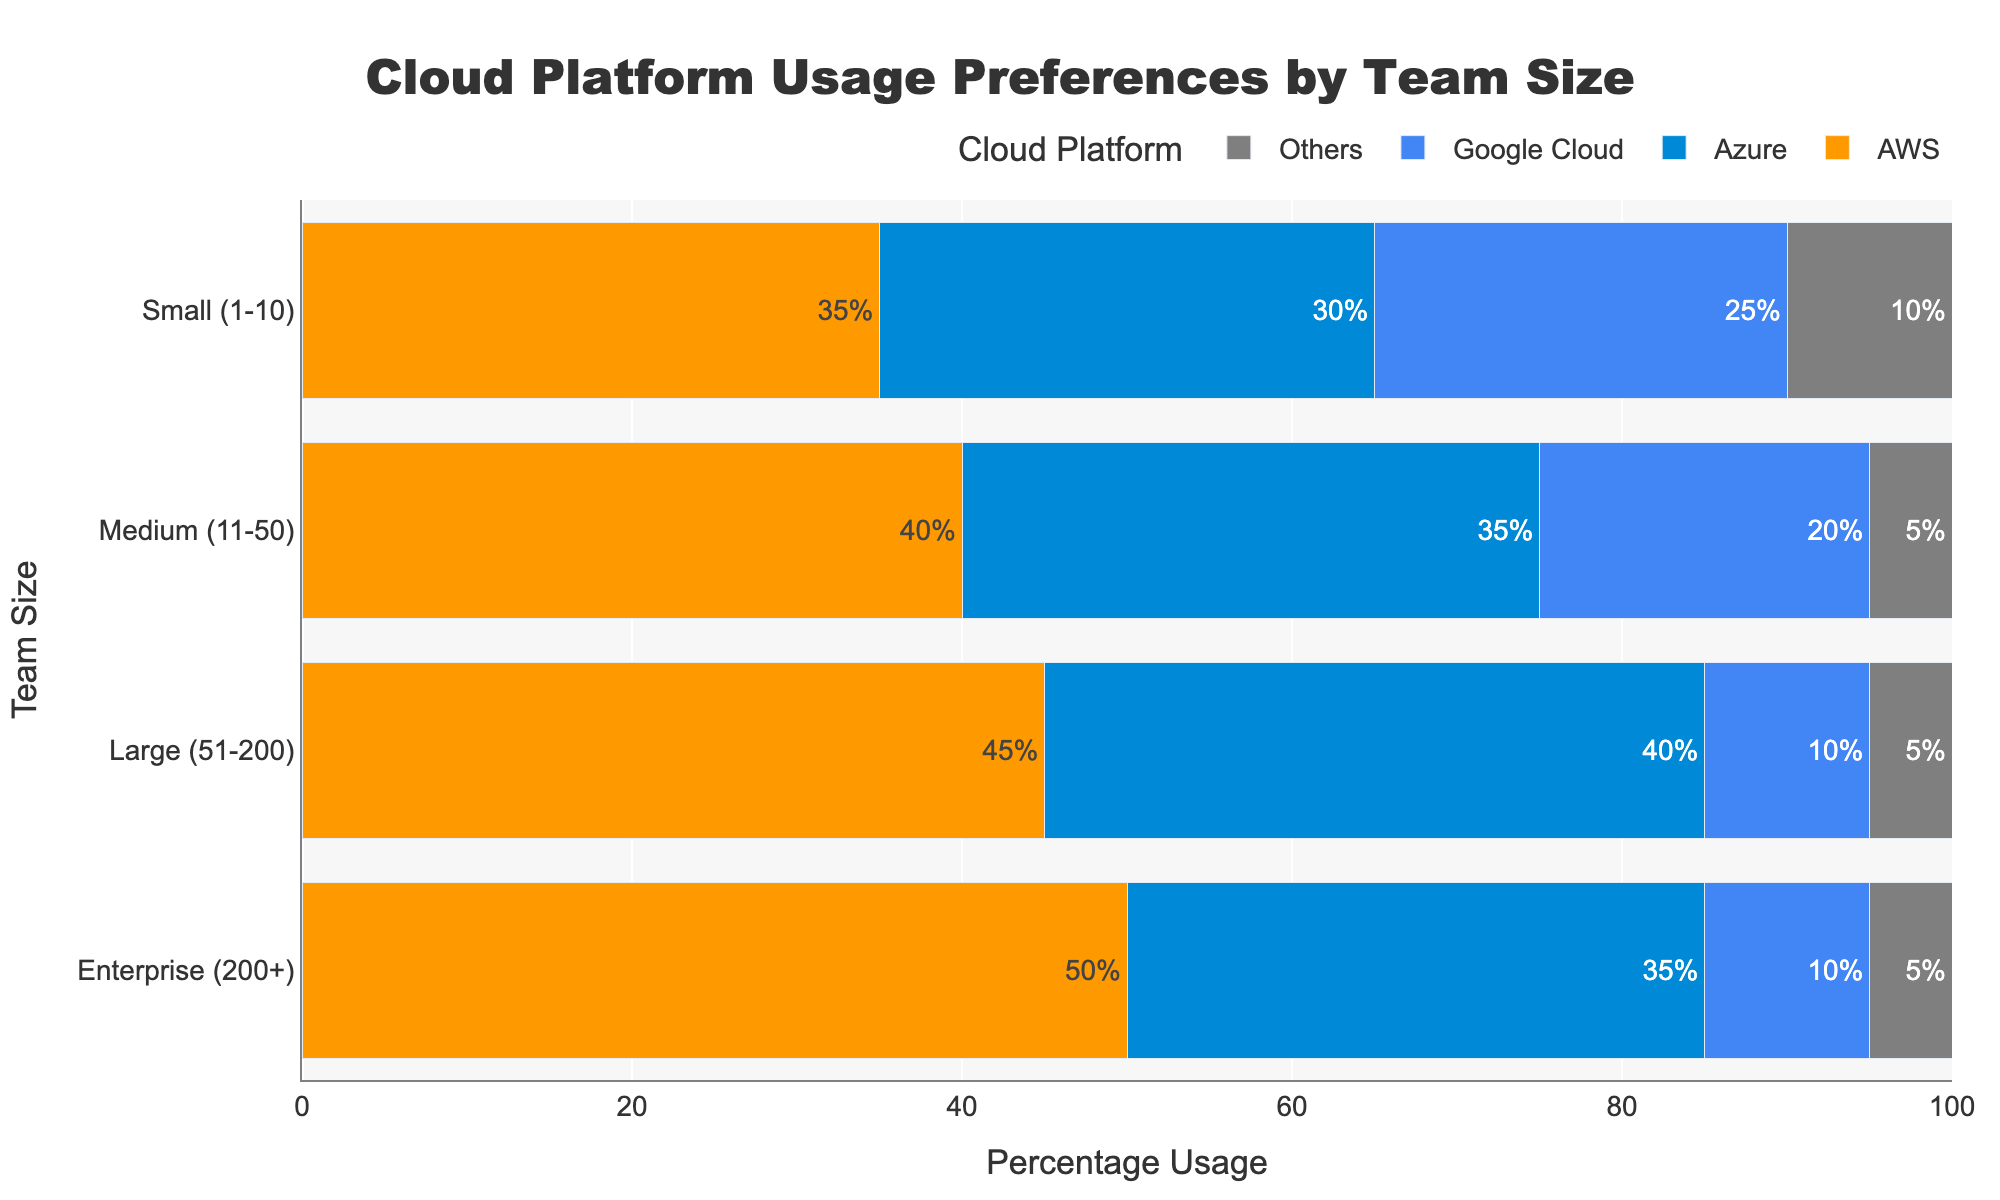what is the most used cloud platform for small teams? By observing the lengths of the bars representing each cloud platform for the 'Small (1-10)' team size, the AWS bar is the longest. Therefore, AWS is the most used cloud platform among small teams.
Answer: AWS how does azure usage compare between medium and large teams? Comparing the bar lengths for Azure between 'Medium (11-50)' and 'Large (51-200)' team sizes, the Azure bar for large teams is longer than the Azure bar for medium teams, indicating higher usage.
Answer: Azure usage is higher for large teams what is the least preferred cloud platform among enterprise teams? By observing the lengths of the bars for each platform for the 'Enterprise (200+)' team size, the bars for Google Cloud and Others are equal and shortest, indicating they are the least preferred.
Answer: Google Cloud and Others what percentage difference exists between the usage of AWS for small and enterprise teams? The AWS usage for small teams is 35%, and for enterprise teams, it is 50%. The percentage difference is 50% - 35% = 15%.
Answer: 15% if we combine the usage percentages of Google Cloud across all team sizes, what total percentage do we get? Adding the usage percentages of Google Cloud for all team sizes: 25% (Small) + 20% (Medium) + 10% (Large) + 10% (Enterprise) = 65%.
Answer: 65% which cloud platform has the most consistent usage percentage across all team sizes? Observing the bars for each platform, AWS has usage percentages of 35%, 40%, 45%, and 50% for increasing team sizes, showing a consistent upward pattern. Other platforms show more variability.
Answer: AWS how much less popular is Google Cloud compared to AWS for medium teams? The AWS usage for medium teams is 40%, while Google Cloud usage is 20%. The difference is 40% - 20% = 20%.
Answer: 20% what proportion of large teams prefer Azure over Google Cloud? For large teams, the Azure usage is 40%, and Google Cloud usage is 10%. To find the proportion, divide Azure usage by the sum of Azure and Google Cloud usage: 40% / (40% + 10%) = 40% / 50% = 0.8.
Answer: 0.8 